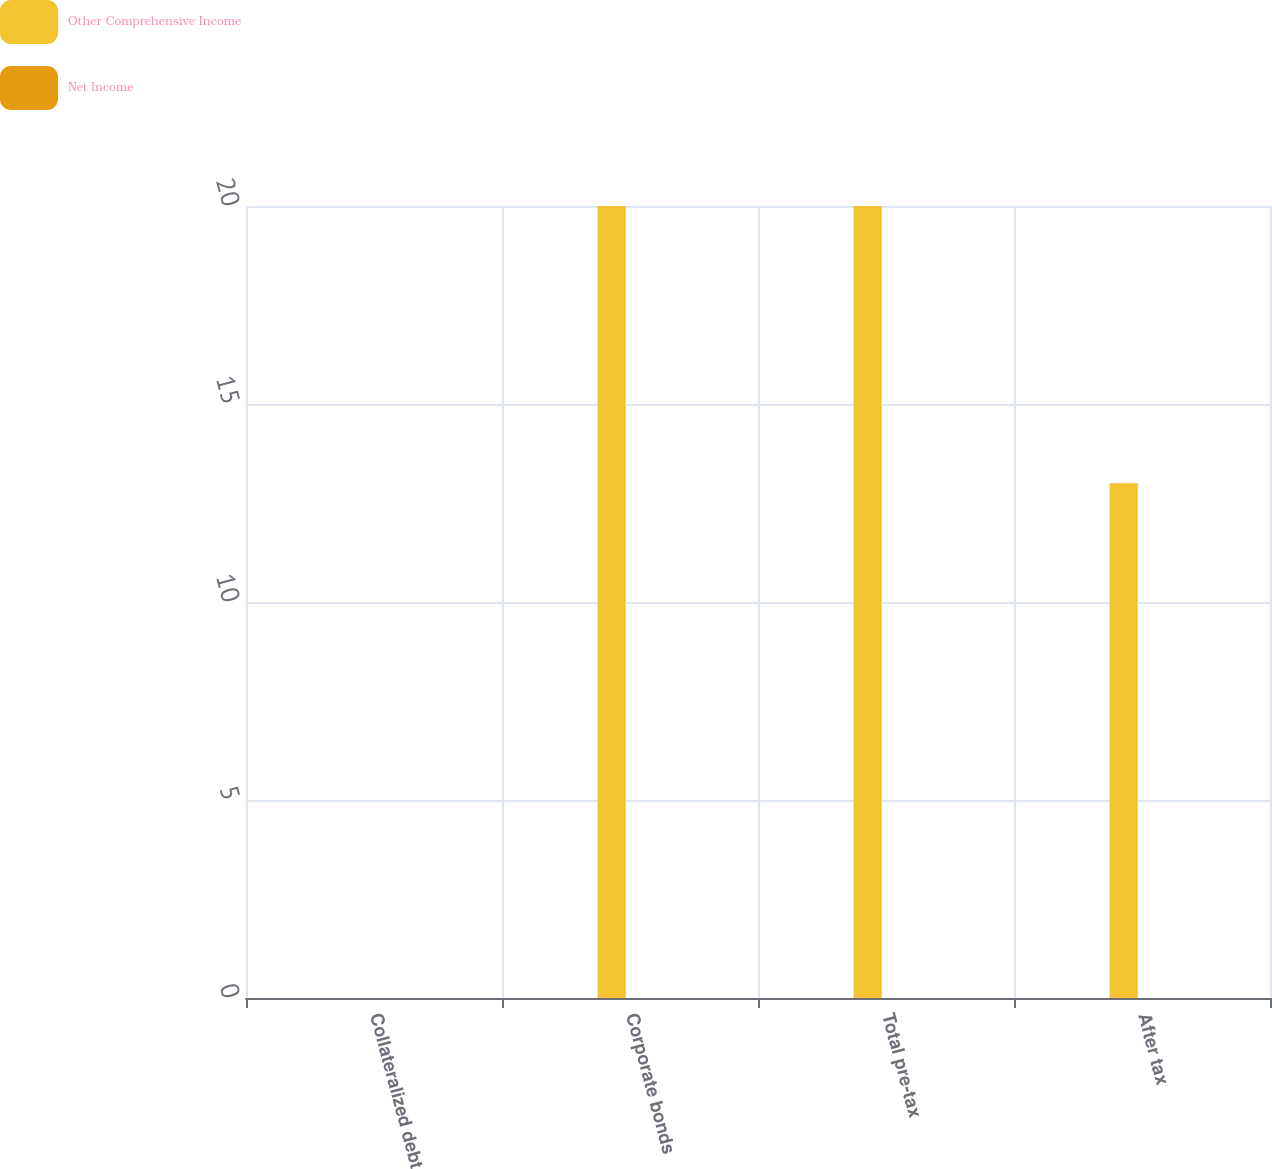Convert chart. <chart><loc_0><loc_0><loc_500><loc_500><stacked_bar_chart><ecel><fcel>Collateralized debt<fcel>Corporate bonds<fcel>Total pre-tax<fcel>After tax<nl><fcel>Other Comprehensive Income<fcel>0<fcel>20<fcel>20<fcel>13<nl><fcel>Net Income<fcel>0<fcel>0<fcel>0<fcel>0<nl></chart> 